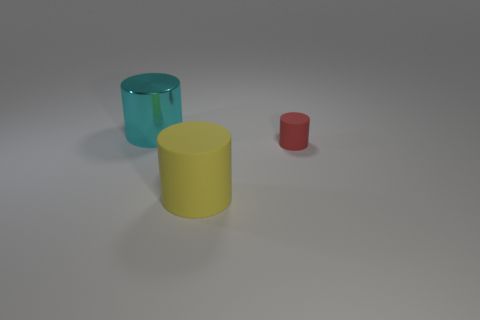There is a cylinder that is both to the left of the red object and in front of the cyan cylinder; what is it made of?
Offer a very short reply. Rubber. Does the thing that is left of the yellow matte cylinder have the same material as the large cylinder that is right of the cyan cylinder?
Provide a succinct answer. No. What size is the shiny object?
Your response must be concise. Large. There is a yellow matte thing that is the same shape as the big cyan shiny object; what size is it?
Provide a succinct answer. Large. There is a small red matte cylinder; what number of large cylinders are in front of it?
Give a very brief answer. 1. The object that is left of the large cylinder in front of the metal object is what color?
Offer a terse response. Cyan. Are there any other things that have the same shape as the small thing?
Your response must be concise. Yes. Are there an equal number of tiny matte cylinders in front of the big yellow matte thing and big cylinders behind the red object?
Provide a short and direct response. No. How many cylinders are either small green rubber things or yellow objects?
Provide a succinct answer. 1. What number of other objects are there of the same material as the small cylinder?
Your response must be concise. 1. 